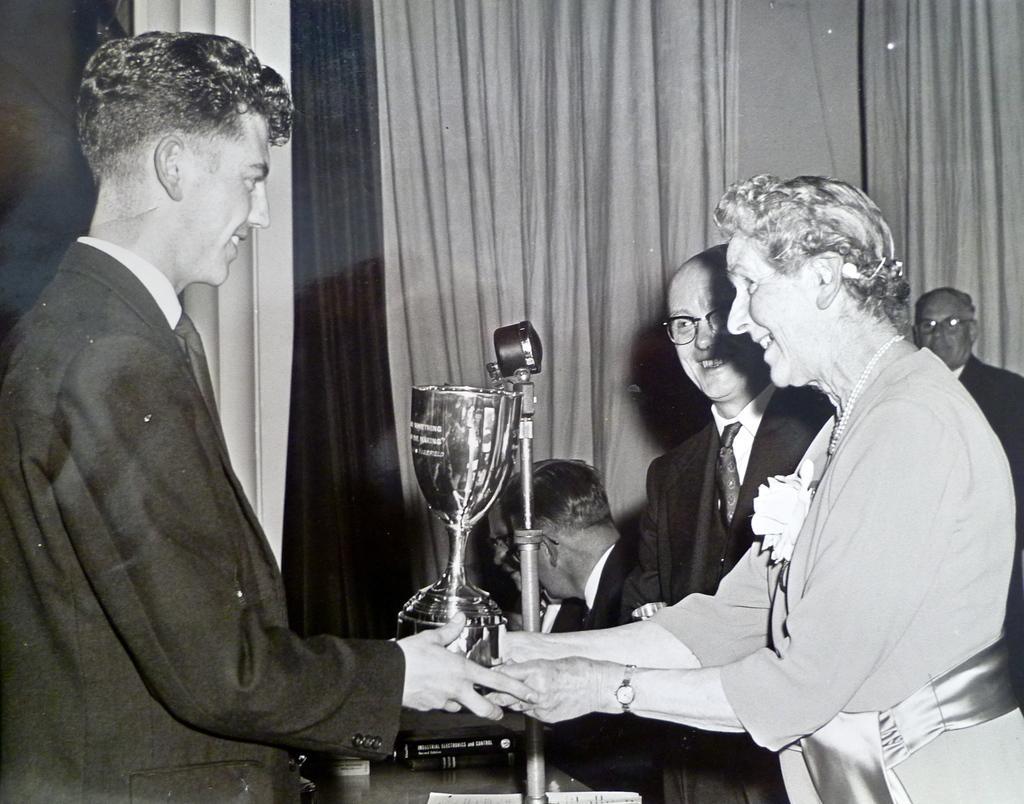How would you summarize this image in a sentence or two? There are two persons standing and holding a gold cup in their hands and there are few other persons in the background. 